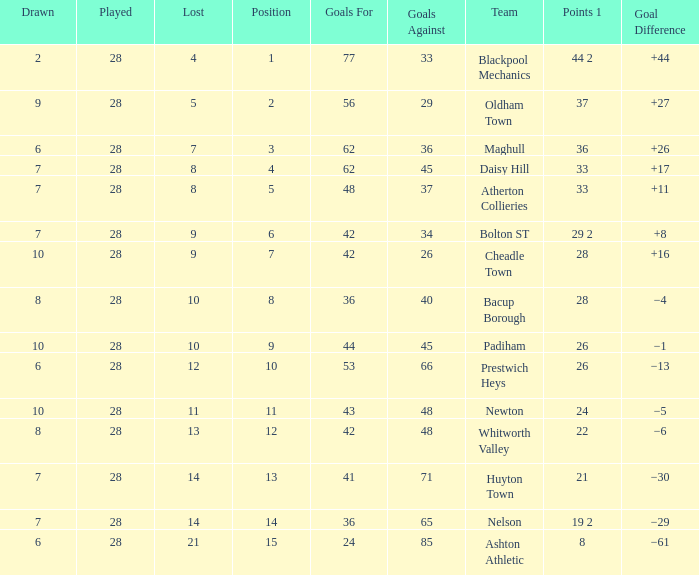For entries with lost larger than 21 and goals for smaller than 36, what is the average drawn? None. 